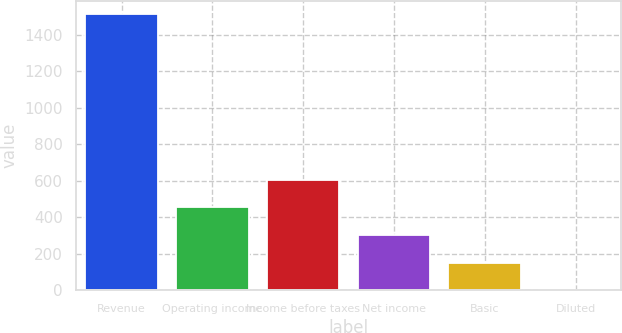Convert chart to OTSL. <chart><loc_0><loc_0><loc_500><loc_500><bar_chart><fcel>Revenue<fcel>Operating income<fcel>Income before taxes<fcel>Net income<fcel>Basic<fcel>Diluted<nl><fcel>1510.6<fcel>454.06<fcel>604.99<fcel>303.13<fcel>152.2<fcel>1.27<nl></chart> 